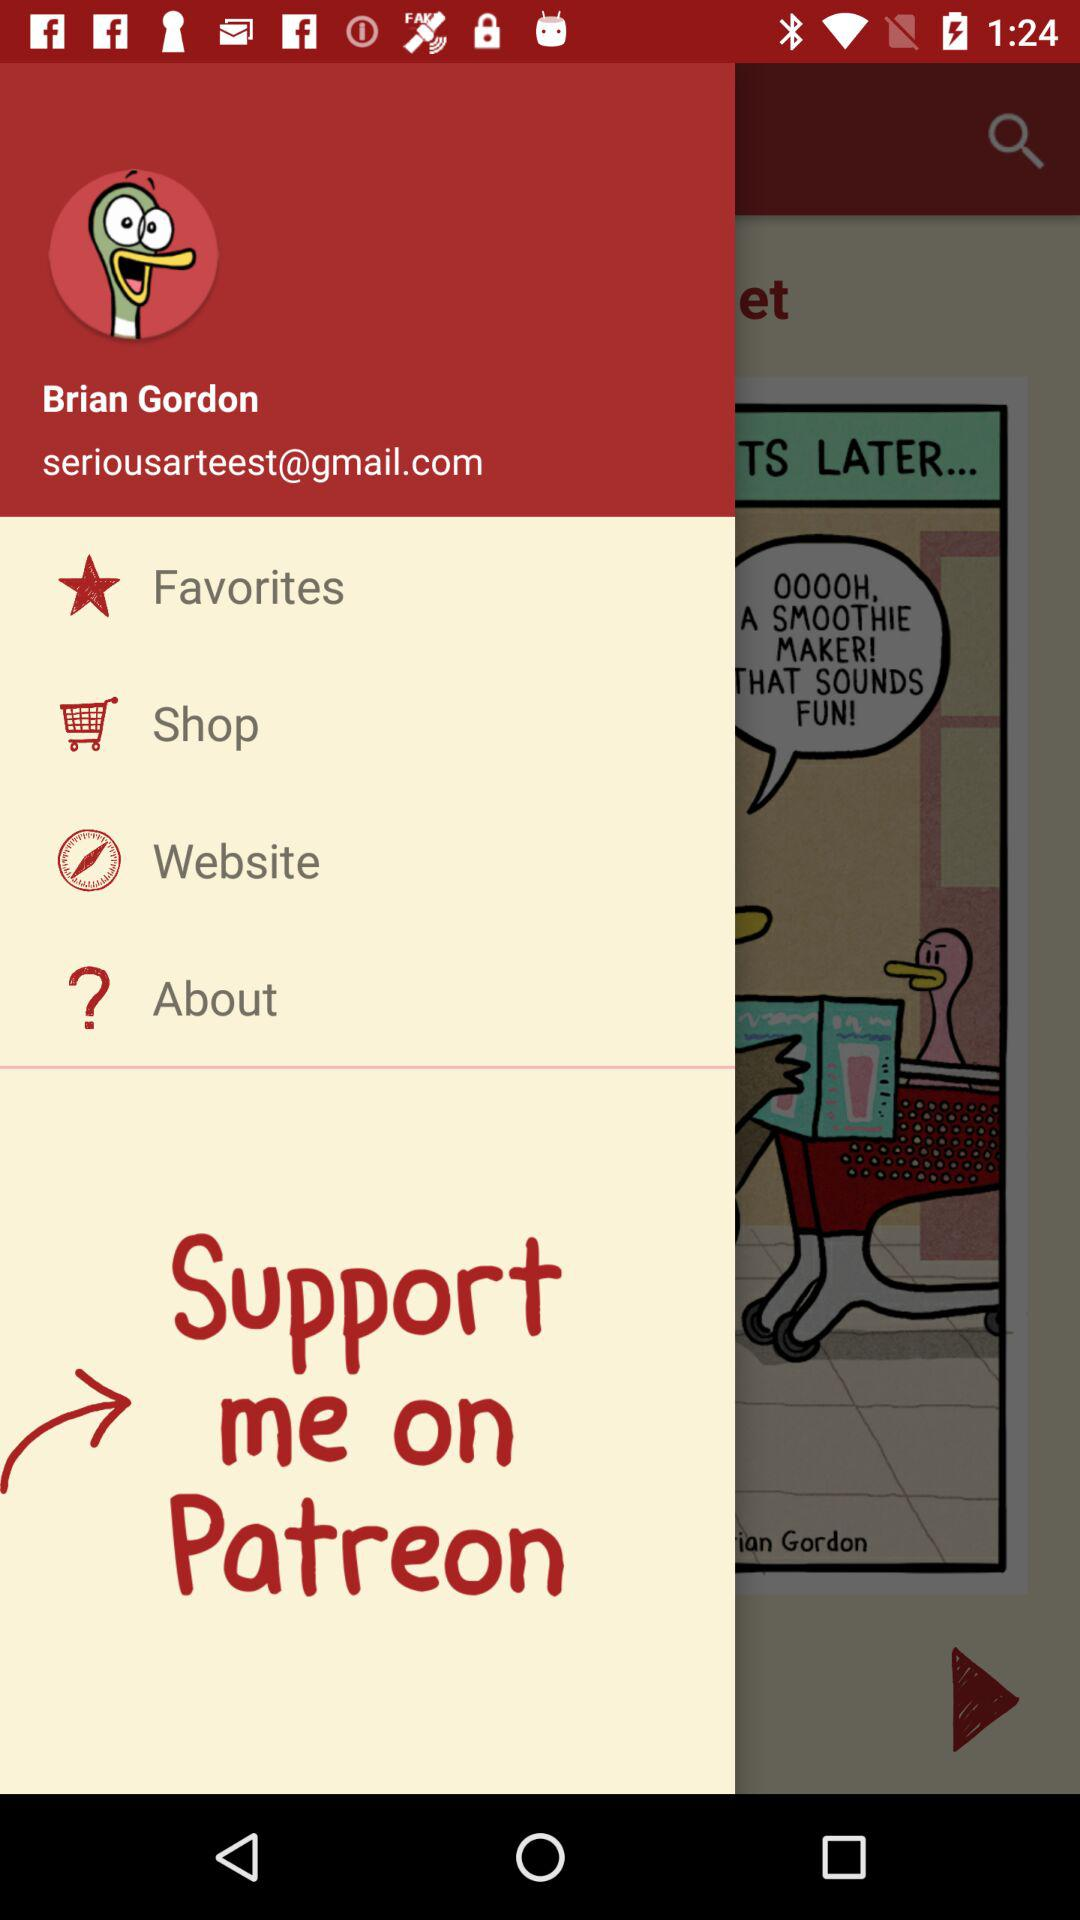What is the user name? The user name is "Brian Gordon". 